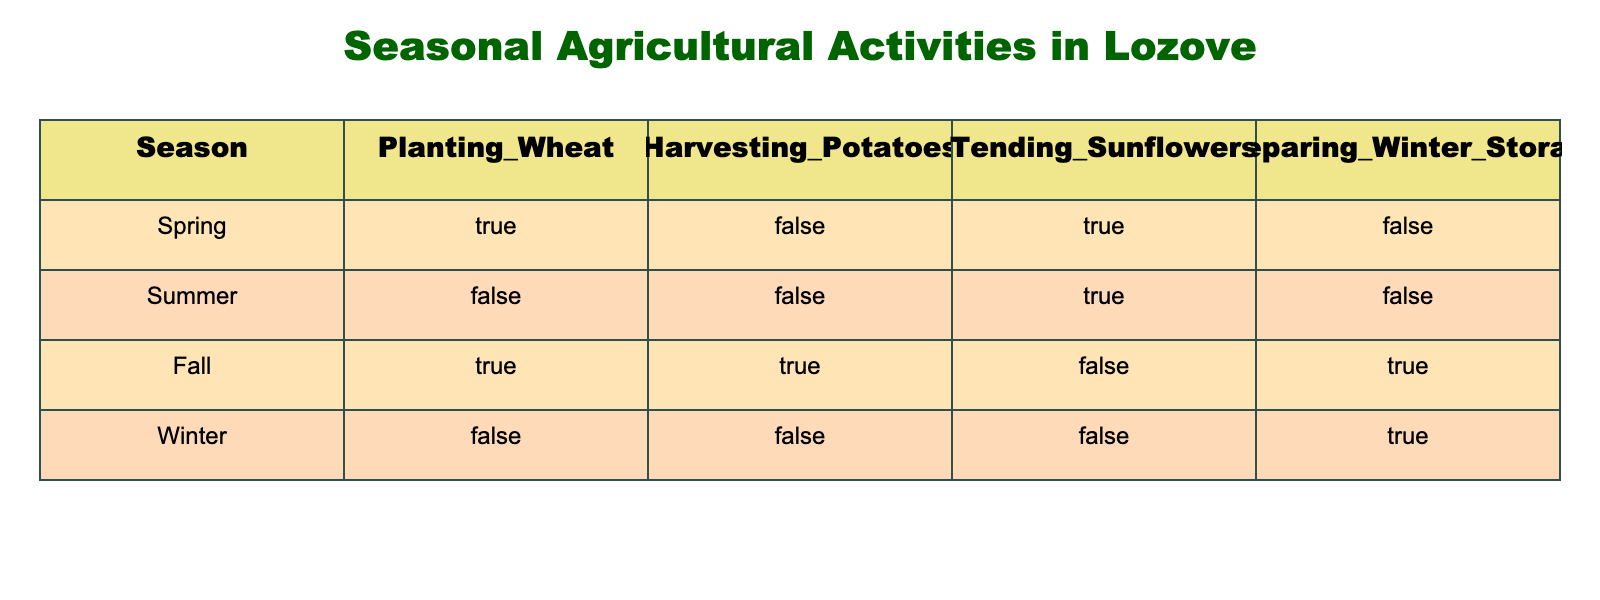What activities occur in Spring? In Spring, the activities listed in the table show that planting wheat and tending sunflowers are undertaken. The values for these activities are TRUE, meaning they occur, while harvesting potatoes and preparing winter storage are FALSE, indicating they do not occur in this season.
Answer: Planting wheat and tending sunflowers How many activities are performed during Fall? In Fall, there are three activities listed: harvesting potatoes, preparing winter storage, and planting wheat, all of which are TRUE for this season. Therefore, there are three activities performed in Fall.
Answer: Three Is it true that we tend sunflowers during Winter? According to the table, tending sunflowers during Winter is marked as FALSE. This means that the activity does not take place in the Winter season.
Answer: No Which season has the highest number of activities taking place? By examining the table, Fall has three activities listed as TRUE (planting wheat, harvesting potatoes, and preparing winter storage), while Spring has two, Summer has one, and Winter has one. Thus, Fall is the season with the highest number of activities.
Answer: Fall What is the total number of activities that occur in the Summer season? In Summer, the table indicates that only tending sunflowers is TRUE (and the other activities are FALSE). Hence, only one activity is performed during the Summer season.
Answer: One Do we harvest potatoes in Spring? The table explicitly states that harvesting potatoes in Spring is marked as FALSE, indicating that this activity does not occur during this season.
Answer: No In how many seasons is preparing winter storage done? Preparing winter storage is marked as FALSE for both Spring and Summer, TRUE for Fall, and TRUE for Winter. Therefore, it occurs in two seasons only, Fall and Winter.
Answer: Two If we wanted to plant wheat and tend sunflowers together, which season would allow both activities? The activities of planting wheat and tending sunflowers are both TRUE in Spring (where planting wheat is TRUE and tending sunflowers is TRUE). Thus, Spring is the only season where we can do both activities together.
Answer: Spring 